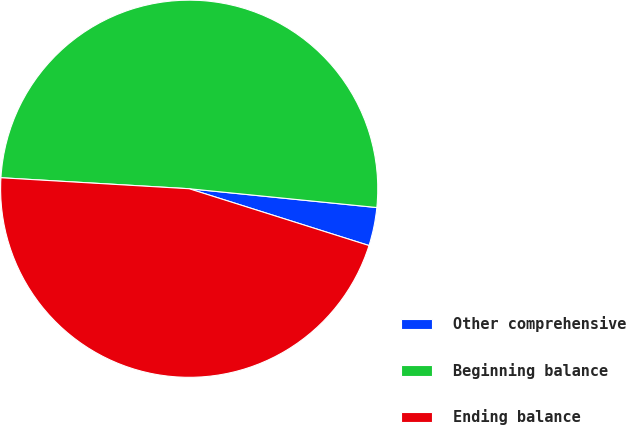<chart> <loc_0><loc_0><loc_500><loc_500><pie_chart><fcel>Other comprehensive<fcel>Beginning balance<fcel>Ending balance<nl><fcel>3.28%<fcel>50.66%<fcel>46.06%<nl></chart> 